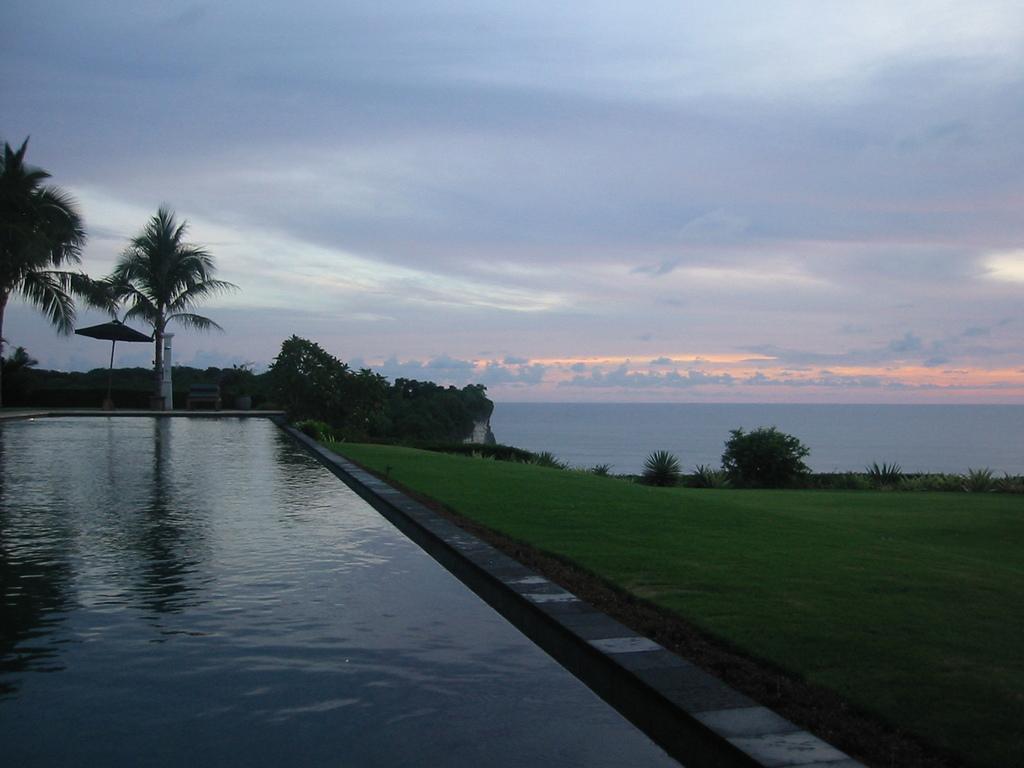How would you summarize this image in a sentence or two? In the picture I can see the water, grassland, trees and the cloudy sky in the background. 